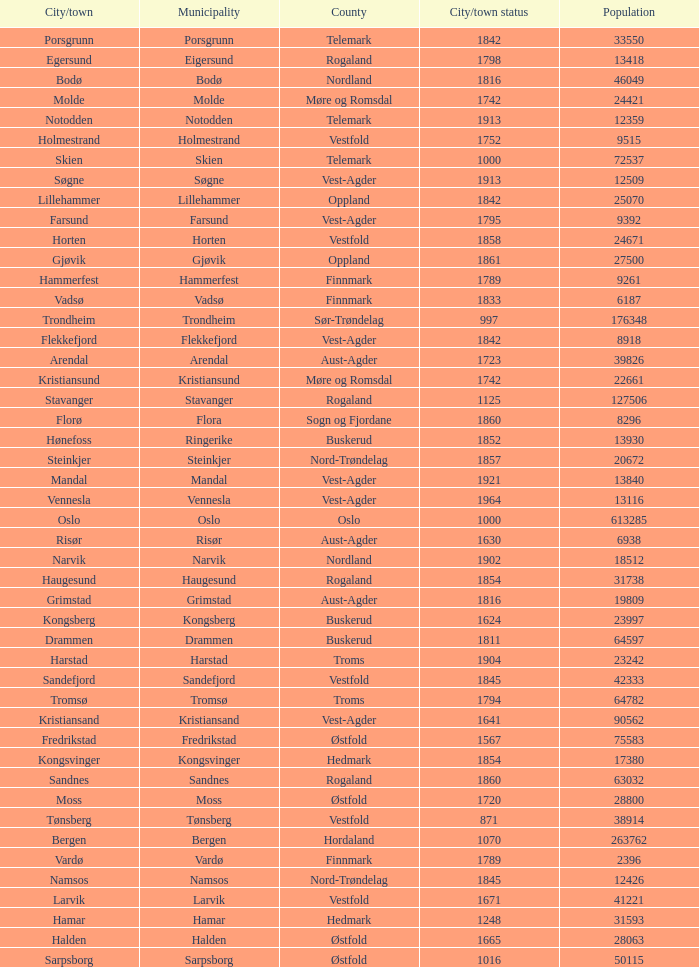In which county is the city/town of Halden located? Østfold. 